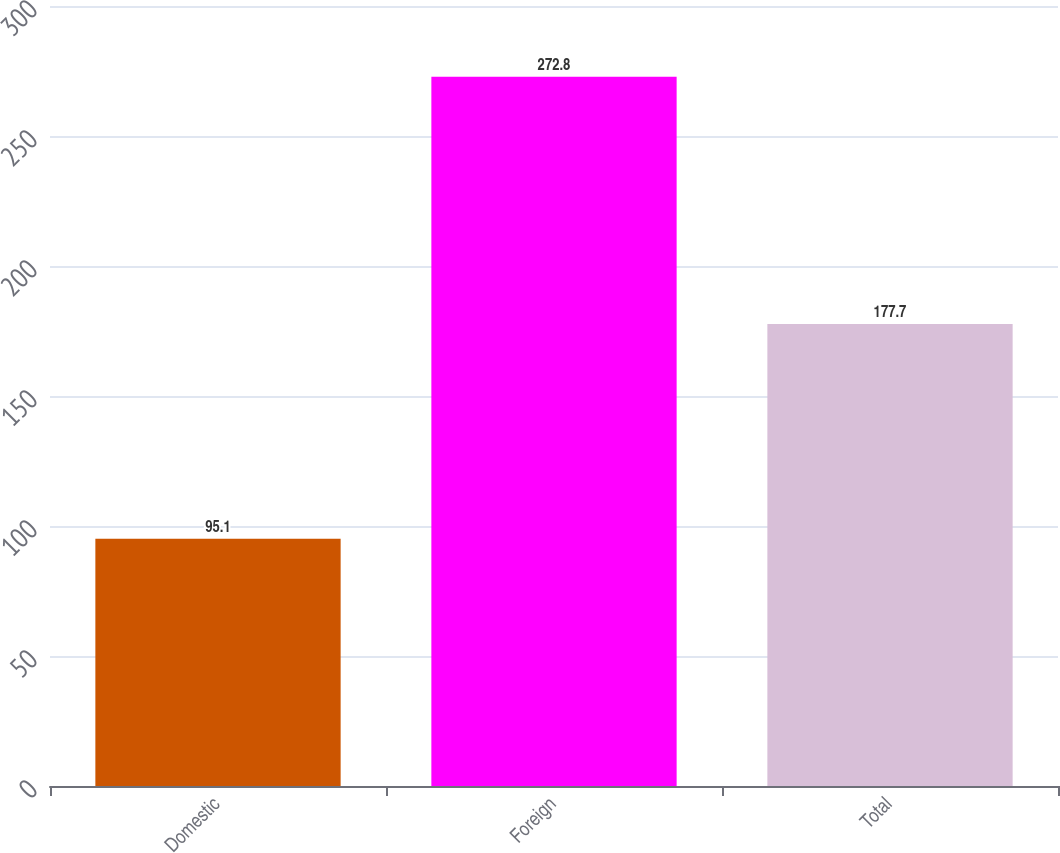<chart> <loc_0><loc_0><loc_500><loc_500><bar_chart><fcel>Domestic<fcel>Foreign<fcel>Total<nl><fcel>95.1<fcel>272.8<fcel>177.7<nl></chart> 